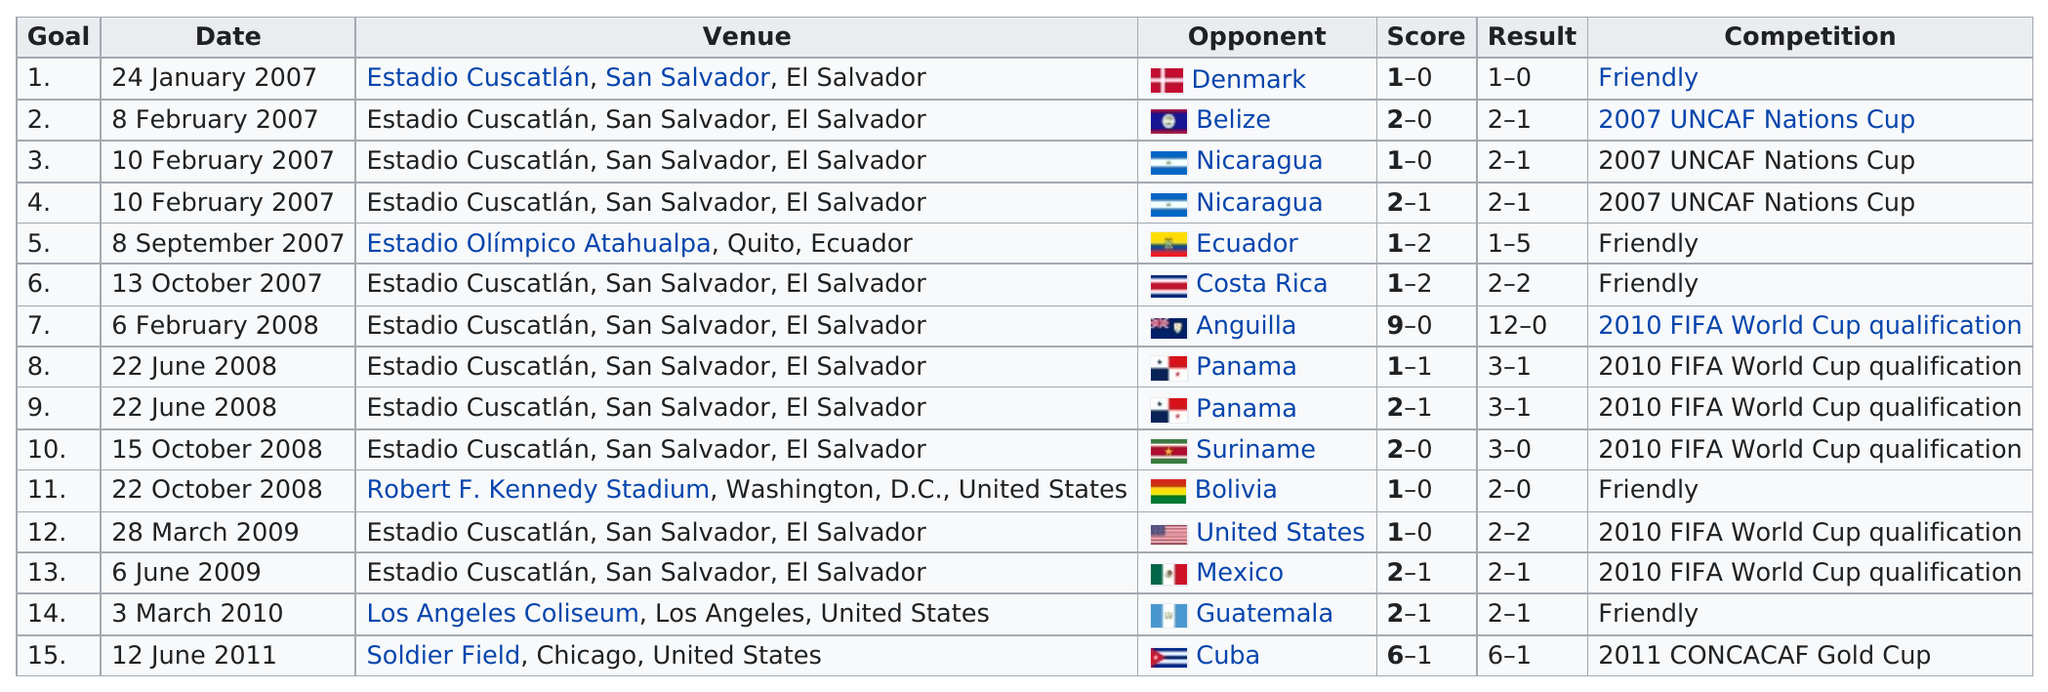List a handful of essential elements in this visual. The 2011 CONCACAF Gold Cup featured the least amount of competition out of all the previous editions. The total number of times that Panama has been the opponent is 2. The most commonly listed type of competition in the provided text is 2010 FIFA World Cup qualification. Nicaragua was listed as the opponent in two occasions The last competition on this chart was the 2011 CONCACAF Gold Cup, which occurred in the year 2011. 